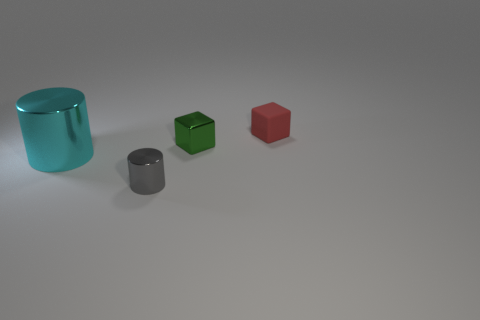Are there any other things that have the same size as the cyan metallic cylinder?
Your response must be concise. No. There is another shiny object that is the same shape as the cyan thing; what is its size?
Keep it short and to the point. Small. The metallic object that is on the left side of the small metallic cylinder has what shape?
Make the answer very short. Cylinder. Does the tiny red matte thing have the same shape as the object to the left of the gray metallic cylinder?
Keep it short and to the point. No. Are there an equal number of tiny red matte objects in front of the gray metallic thing and tiny cylinders left of the cyan metallic cylinder?
Your response must be concise. Yes. Are there more small rubber things that are behind the tiny metal cylinder than purple metallic cubes?
Make the answer very short. Yes. What is the tiny cylinder made of?
Offer a very short reply. Metal. There is a large object that is the same material as the small cylinder; what is its shape?
Give a very brief answer. Cylinder. There is a cube that is left of the thing that is behind the green thing; what is its size?
Your answer should be compact. Small. What is the color of the cube in front of the tiny matte thing?
Ensure brevity in your answer.  Green. 